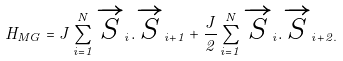<formula> <loc_0><loc_0><loc_500><loc_500>H _ { M G } = J \sum ^ { N } _ { i = 1 } \overrightarrow { S } _ { i } . \overrightarrow { S } _ { i + 1 } + \frac { J } { 2 } \sum ^ { N } _ { i = 1 } \overrightarrow { S } _ { i } . \overrightarrow { S } _ { i + 2 . }</formula> 